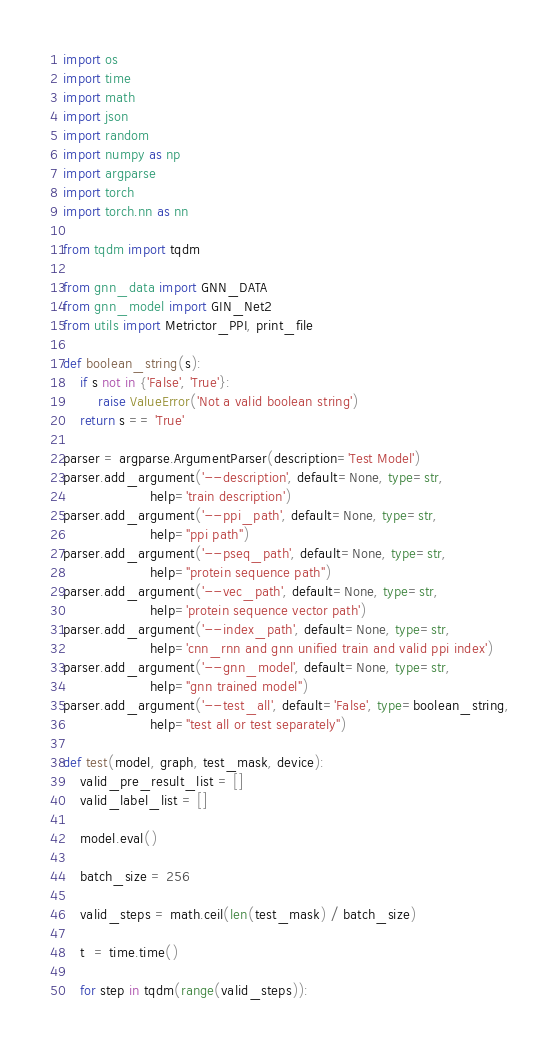Convert code to text. <code><loc_0><loc_0><loc_500><loc_500><_Python_>import os
import time
import math
import json
import random
import numpy as np
import argparse
import torch
import torch.nn as nn

from tqdm import tqdm

from gnn_data import GNN_DATA
from gnn_model import GIN_Net2
from utils import Metrictor_PPI, print_file

def boolean_string(s):
    if s not in {'False', 'True'}:
        raise ValueError('Not a valid boolean string')
    return s == 'True'

parser = argparse.ArgumentParser(description='Test Model')
parser.add_argument('--description', default=None, type=str,
                    help='train description')
parser.add_argument('--ppi_path', default=None, type=str,
                    help="ppi path")
parser.add_argument('--pseq_path', default=None, type=str,
                    help="protein sequence path")
parser.add_argument('--vec_path', default=None, type=str,
                    help='protein sequence vector path')
parser.add_argument('--index_path', default=None, type=str,
                    help='cnn_rnn and gnn unified train and valid ppi index')
parser.add_argument('--gnn_model', default=None, type=str,
                    help="gnn trained model")
parser.add_argument('--test_all', default='False', type=boolean_string,
                    help="test all or test separately")

def test(model, graph, test_mask, device):
    valid_pre_result_list = []
    valid_label_list = []

    model.eval()

    batch_size = 256

    valid_steps = math.ceil(len(test_mask) / batch_size)

    t  = time.time()

    for step in tqdm(range(valid_steps)):</code> 